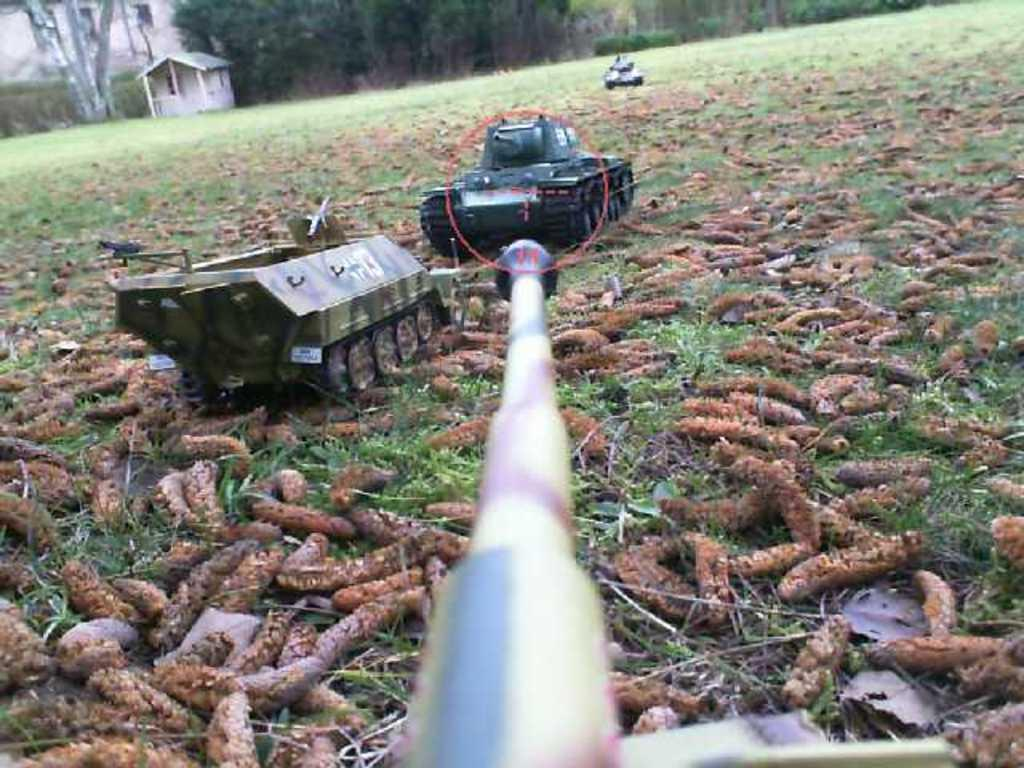What objects can be seen in the image? There are toys in the image. What is on the grass in the image? There is something on the grass in the image, but the specific object is not mentioned in the facts. What can be seen in the background of the image? Trees and a house are visible at the top of the image. What type of celery is being used as a toy in the image? There is no celery present in the image; it only mentions toys as the objects in the image. What is the purpose of the house in the image? The facts do not mention the purpose of the house in the image, only that it is visible at the top of the image. 